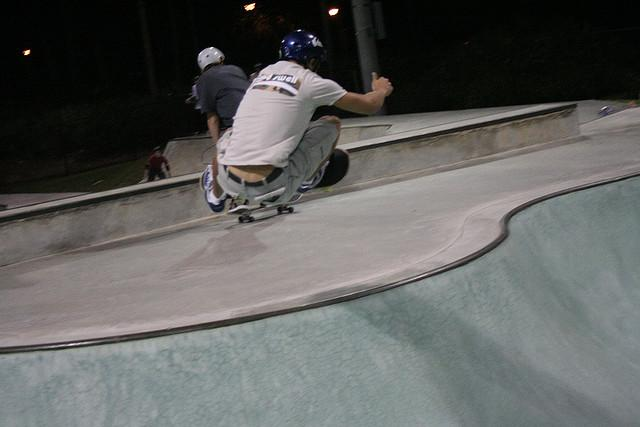World skate is the head controller of which game?

Choices:
A) kiting
B) swimming
C) skating
D) snowboarding skating 